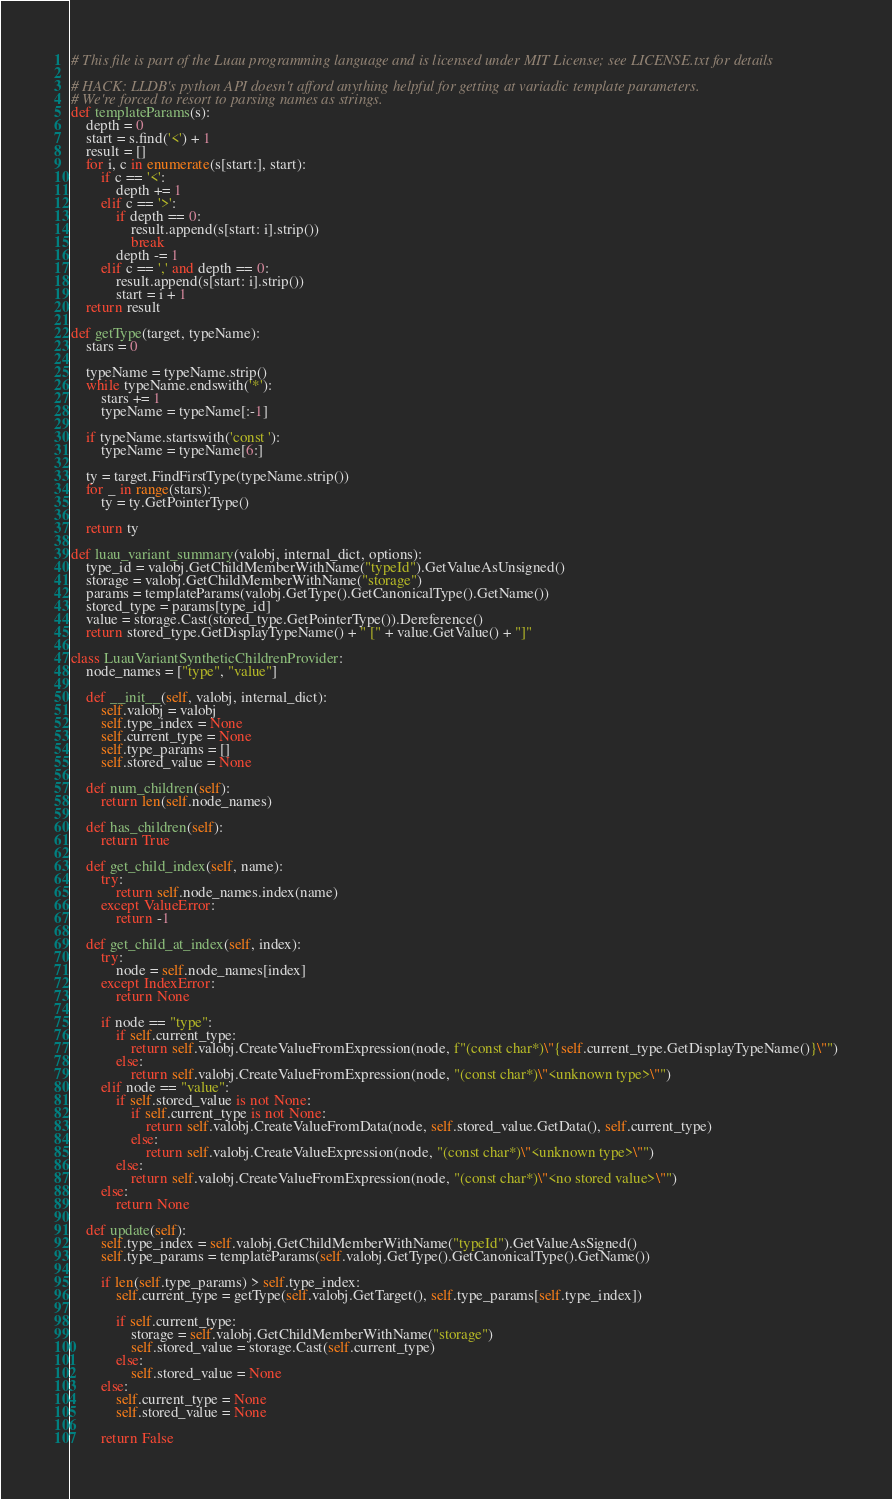Convert code to text. <code><loc_0><loc_0><loc_500><loc_500><_Python_># This file is part of the Luau programming language and is licensed under MIT License; see LICENSE.txt for details

# HACK: LLDB's python API doesn't afford anything helpful for getting at variadic template parameters.
# We're forced to resort to parsing names as strings.
def templateParams(s):
    depth = 0
    start = s.find('<') + 1
    result = []
    for i, c in enumerate(s[start:], start):
        if c == '<':
            depth += 1
        elif c == '>':
            if depth == 0:
                result.append(s[start: i].strip())
                break
            depth -= 1
        elif c == ',' and depth == 0:
            result.append(s[start: i].strip())
            start = i + 1
    return result

def getType(target, typeName):
    stars = 0

    typeName = typeName.strip()
    while typeName.endswith('*'):
        stars += 1
        typeName = typeName[:-1]

    if typeName.startswith('const '):
        typeName = typeName[6:]

    ty = target.FindFirstType(typeName.strip())
    for _ in range(stars):
        ty = ty.GetPointerType()

    return ty

def luau_variant_summary(valobj, internal_dict, options):
    type_id = valobj.GetChildMemberWithName("typeId").GetValueAsUnsigned()
    storage = valobj.GetChildMemberWithName("storage")
    params = templateParams(valobj.GetType().GetCanonicalType().GetName())
    stored_type = params[type_id]
    value = storage.Cast(stored_type.GetPointerType()).Dereference()
    return stored_type.GetDisplayTypeName() + " [" + value.GetValue() + "]"

class LuauVariantSyntheticChildrenProvider:
    node_names = ["type", "value"]

    def __init__(self, valobj, internal_dict):
        self.valobj = valobj
        self.type_index = None
        self.current_type = None
        self.type_params = []
        self.stored_value = None

    def num_children(self):
        return len(self.node_names)

    def has_children(self):
        return True

    def get_child_index(self, name):
        try:
            return self.node_names.index(name)
        except ValueError:
            return -1

    def get_child_at_index(self, index):
        try:
            node = self.node_names[index]
        except IndexError:
            return None

        if node == "type":
            if self.current_type:
                return self.valobj.CreateValueFromExpression(node, f"(const char*)\"{self.current_type.GetDisplayTypeName()}\"")
            else:
                return self.valobj.CreateValueFromExpression(node, "(const char*)\"<unknown type>\"")
        elif node == "value":
            if self.stored_value is not None:
                if self.current_type is not None:
                    return self.valobj.CreateValueFromData(node, self.stored_value.GetData(), self.current_type)
                else:
                    return self.valobj.CreateValueExpression(node, "(const char*)\"<unknown type>\"")
            else:
                return self.valobj.CreateValueFromExpression(node, "(const char*)\"<no stored value>\"")
        else:
            return None

    def update(self):
        self.type_index = self.valobj.GetChildMemberWithName("typeId").GetValueAsSigned()
        self.type_params = templateParams(self.valobj.GetType().GetCanonicalType().GetName())

        if len(self.type_params) > self.type_index:
            self.current_type = getType(self.valobj.GetTarget(), self.type_params[self.type_index])

            if self.current_type:
                storage = self.valobj.GetChildMemberWithName("storage")
                self.stored_value = storage.Cast(self.current_type)
            else:
                self.stored_value = None
        else:
            self.current_type = None
            self.stored_value = None

        return False
</code> 